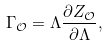Convert formula to latex. <formula><loc_0><loc_0><loc_500><loc_500>\Gamma _ { \mathcal { O } } = \Lambda { \frac { { \partial Z _ { \mathcal { O } } } } { \partial \Lambda } , }</formula> 